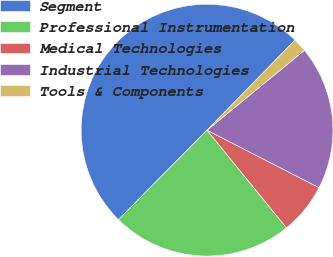<chart> <loc_0><loc_0><loc_500><loc_500><pie_chart><fcel>Segment<fcel>Professional Instrumentation<fcel>Medical Technologies<fcel>Industrial Technologies<fcel>Tools & Components<nl><fcel>49.89%<fcel>23.29%<fcel>6.58%<fcel>18.48%<fcel>1.76%<nl></chart> 